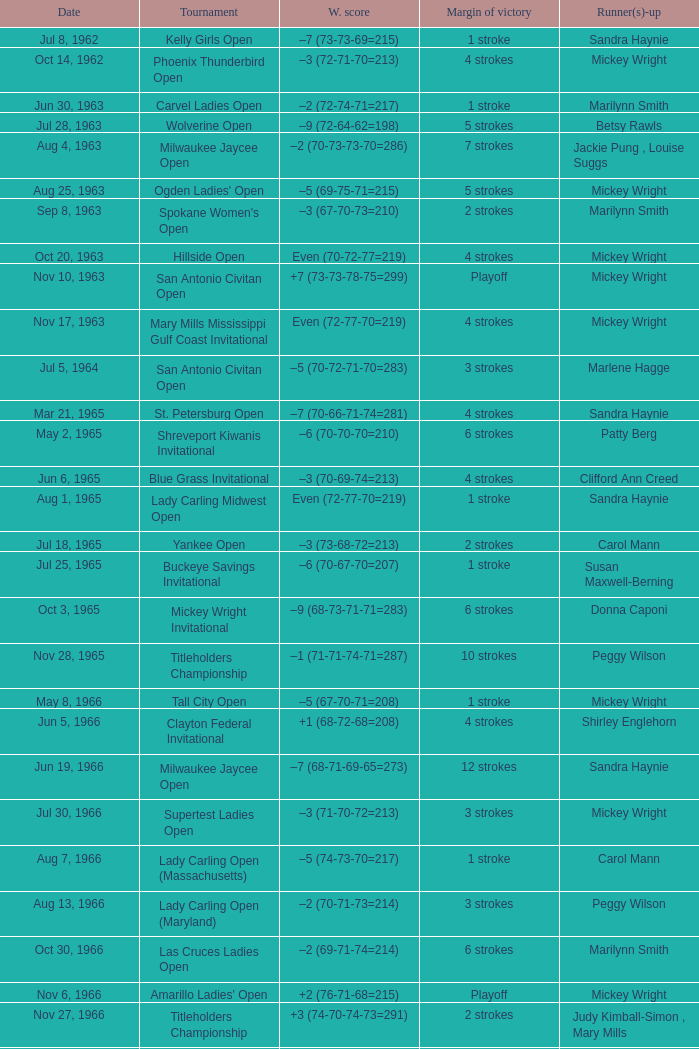What was the winning score when there were 9 strokes advantage? –7 (73-68-73-67=281). 